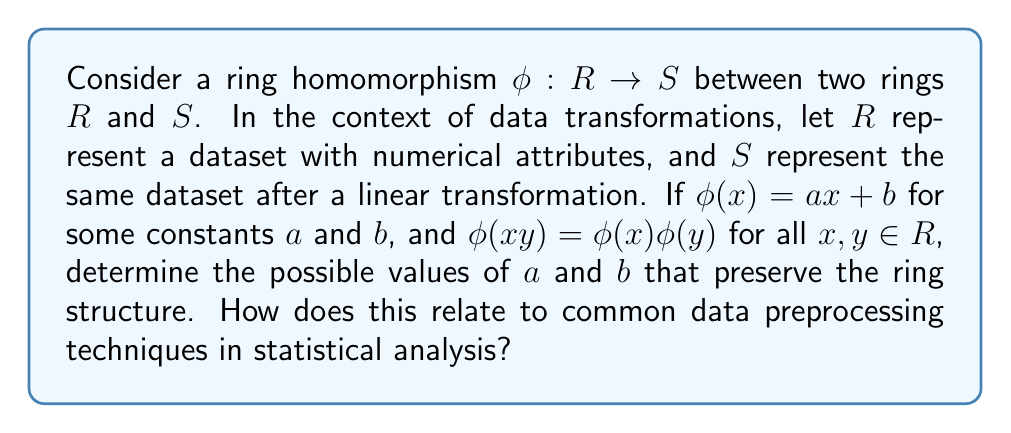Can you solve this math problem? To solve this problem, we need to consider the properties of ring homomorphisms and how they relate to linear transformations in data science:

1) First, recall that a ring homomorphism preserves both addition and multiplication:
   $\phi(x + y) = \phi(x) + \phi(y)$ and $\phi(xy) = \phi(x)\phi(y)$

2) Given $\phi(x) = ax + b$, let's consider the multiplication property:
   $\phi(xy) = \phi(x)\phi(y)$
   $a(xy) + b = (ax + b)(ay + b)$
   $axy + b = a^2xy + aby + abx + b^2$

3) For this to hold for all $x$ and $y$, we must have:
   $axy = a^2xy$
   $b = aby + abx + b^2$

4) From the first equation: $a = a^2$ or $a = 0$ or $a = 1$

5) From the second equation:
   If $a = 1$, then $b = b + b + b^2$, which implies $b = 0$
   If $a = 0$, then $b = b^2$, which implies $b = 0$ or $b = 1$

6) Therefore, the possible transformations are:
   $\phi(x) = x$ (identity transformation)
   $\phi(x) = 0$ (zero transformation)
   $\phi(x) = 0x + 1 = 1$ (constant transformation)

7) In terms of data preprocessing:
   - The identity transformation ($\phi(x) = x$) represents no change to the data.
   - The zero transformation ($\phi(x) = 0$) is analogous to setting all values to zero, which is rarely used but could represent a form of data masking.
   - The constant transformation ($\phi(x) = 1$) is similar to one-hot encoding, where all non-zero values are set to 1.

8) Notably absent are scaling ($\phi(x) = ax$ where $a \neq 0,1$) and translation ($\phi(x) = x + b$ where $b \neq 0$), which are common in data preprocessing but do not preserve the ring structure under multiplication.
Answer: The possible values for $a$ and $b$ that preserve the ring structure are:
1) $a = 1$ and $b = 0$ (identity transformation)
2) $a = 0$ and $b = 0$ (zero transformation)
3) $a = 0$ and $b = 1$ (constant transformation)

These transformations relate to data preprocessing by representing no change, data masking, and a form of binary encoding, respectively. Common preprocessing techniques like scaling and translation are not ring homomorphisms, highlighting the constraints that algebraic structures can impose on data transformations. 